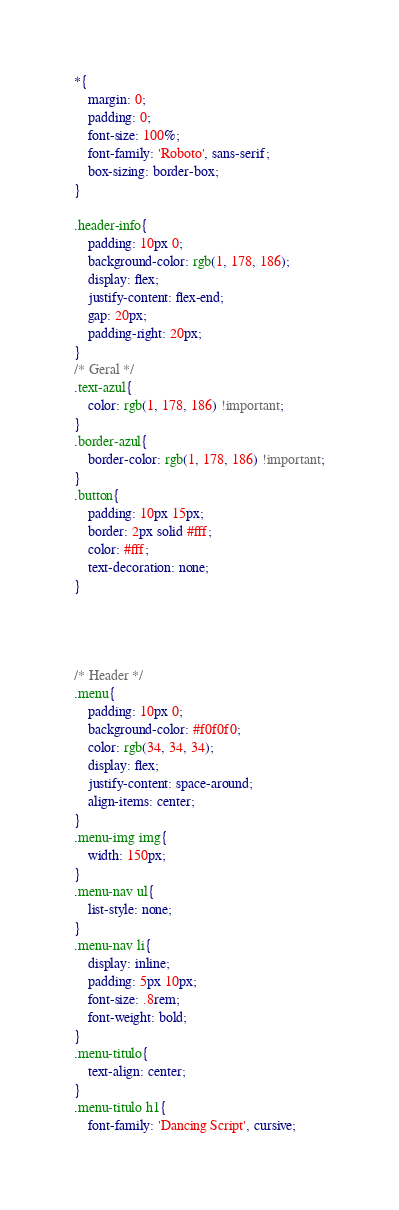Convert code to text. <code><loc_0><loc_0><loc_500><loc_500><_CSS_>*{
    margin: 0;
    padding: 0;
    font-size: 100%;
    font-family: 'Roboto', sans-serif;
    box-sizing: border-box;
}

.header-info{
    padding: 10px 0;
    background-color: rgb(1, 178, 186);
    display: flex;
    justify-content: flex-end;
    gap: 20px;
    padding-right: 20px;
}
/* Geral */
.text-azul{
    color: rgb(1, 178, 186) !important;
}
.border-azul{
    border-color: rgb(1, 178, 186) !important;
}
.button{
    padding: 10px 15px;
    border: 2px solid #fff;
    color: #fff;
    text-decoration: none;
}




/* Header */
.menu{
    padding: 10px 0;
    background-color: #f0f0f0;
    color: rgb(34, 34, 34);
    display: flex;
    justify-content: space-around;
    align-items: center;
}
.menu-img img{
    width: 150px;
}
.menu-nav ul{
    list-style: none;
}
.menu-nav li{
    display: inline;
    padding: 5px 10px;
    font-size: .8rem;
    font-weight: bold;
}
.menu-titulo{
    text-align: center;
}
.menu-titulo h1{
    font-family: 'Dancing Script', cursive;</code> 